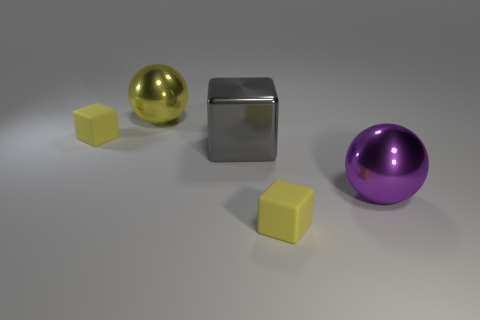What number of things are left of the big purple ball and in front of the gray metal block?
Ensure brevity in your answer.  1. How many blocks are behind the ball that is right of the shiny object behind the gray shiny object?
Your answer should be very brief. 2. The tiny object that is in front of the small rubber thing behind the purple shiny sphere is what color?
Offer a terse response. Yellow. What number of other objects are there of the same material as the big purple sphere?
Provide a succinct answer. 2. There is a small matte cube that is behind the big purple metallic thing; how many small yellow cubes are right of it?
Keep it short and to the point. 1. There is a cube that is to the left of the big cube; does it have the same color as the big object behind the gray thing?
Provide a succinct answer. Yes. Are there fewer large gray metallic blocks than small yellow matte cubes?
Provide a succinct answer. Yes. The yellow rubber thing that is behind the large purple ball that is in front of the big yellow metal object is what shape?
Your answer should be compact. Cube. The big yellow thing left of the large ball that is on the right side of the yellow matte cube right of the big yellow object is what shape?
Keep it short and to the point. Sphere. What number of objects are either yellow matte cubes that are in front of the purple thing or yellow rubber blocks in front of the large purple metallic ball?
Provide a short and direct response. 1. 